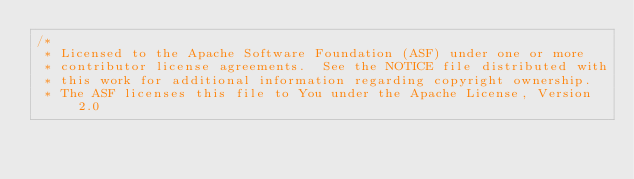Convert code to text. <code><loc_0><loc_0><loc_500><loc_500><_Scala_>/*
 * Licensed to the Apache Software Foundation (ASF) under one or more
 * contributor license agreements.  See the NOTICE file distributed with
 * this work for additional information regarding copyright ownership.
 * The ASF licenses this file to You under the Apache License, Version 2.0</code> 